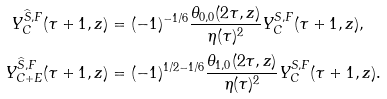Convert formula to latex. <formula><loc_0><loc_0><loc_500><loc_500>Y ^ { \widehat { S } , F } _ { C } ( \tau + 1 , z ) & = ( - 1 ) ^ { - 1 / 6 } \frac { \theta _ { 0 , 0 } ( 2 \tau , z ) } { \eta ( \tau ) ^ { 2 } } Y ^ { S , F } _ { C } ( \tau + 1 , z ) , \\ Y ^ { \widehat { S } , F } _ { C + E } ( \tau + 1 , z ) & = ( - 1 ) ^ { 1 / 2 - 1 / 6 } \frac { \theta _ { 1 , 0 } ( 2 \tau , z ) } { \eta ( \tau ) ^ { 2 } } Y ^ { S , F } _ { C } ( \tau + 1 , z ) .</formula> 